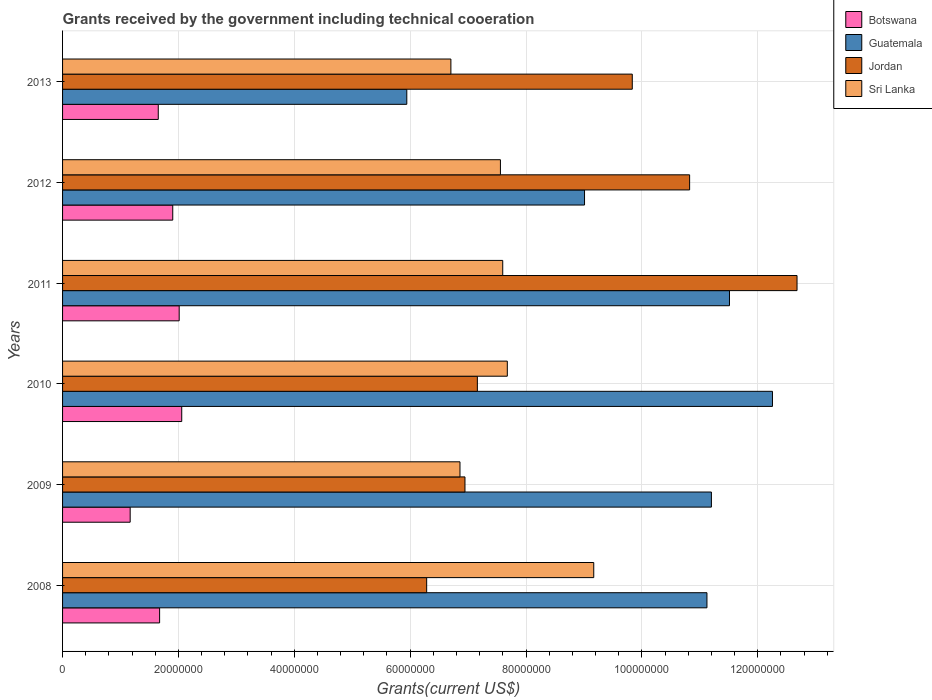How many different coloured bars are there?
Make the answer very short. 4. In how many cases, is the number of bars for a given year not equal to the number of legend labels?
Your answer should be very brief. 0. What is the total grants received by the government in Jordan in 2011?
Make the answer very short. 1.27e+08. Across all years, what is the maximum total grants received by the government in Sri Lanka?
Ensure brevity in your answer.  9.17e+07. Across all years, what is the minimum total grants received by the government in Guatemala?
Give a very brief answer. 5.94e+07. In which year was the total grants received by the government in Jordan minimum?
Offer a terse response. 2008. What is the total total grants received by the government in Jordan in the graph?
Your response must be concise. 5.37e+08. What is the difference between the total grants received by the government in Sri Lanka in 2010 and that in 2012?
Provide a succinct answer. 1.19e+06. What is the difference between the total grants received by the government in Guatemala in 2010 and the total grants received by the government in Sri Lanka in 2013?
Offer a terse response. 5.55e+07. What is the average total grants received by the government in Guatemala per year?
Offer a very short reply. 1.02e+08. In the year 2013, what is the difference between the total grants received by the government in Botswana and total grants received by the government in Sri Lanka?
Your answer should be compact. -5.05e+07. What is the ratio of the total grants received by the government in Botswana in 2009 to that in 2012?
Ensure brevity in your answer.  0.61. What is the difference between the highest and the second highest total grants received by the government in Guatemala?
Give a very brief answer. 7.42e+06. What is the difference between the highest and the lowest total grants received by the government in Guatemala?
Provide a succinct answer. 6.31e+07. In how many years, is the total grants received by the government in Jordan greater than the average total grants received by the government in Jordan taken over all years?
Provide a short and direct response. 3. What does the 4th bar from the top in 2012 represents?
Make the answer very short. Botswana. What does the 3rd bar from the bottom in 2011 represents?
Make the answer very short. Jordan. How many bars are there?
Offer a very short reply. 24. Are all the bars in the graph horizontal?
Your answer should be compact. Yes. How many years are there in the graph?
Offer a very short reply. 6. What is the difference between two consecutive major ticks on the X-axis?
Your answer should be very brief. 2.00e+07. Does the graph contain any zero values?
Your response must be concise. No. Does the graph contain grids?
Your response must be concise. Yes. Where does the legend appear in the graph?
Provide a short and direct response. Top right. What is the title of the graph?
Your answer should be very brief. Grants received by the government including technical cooeration. What is the label or title of the X-axis?
Offer a very short reply. Grants(current US$). What is the label or title of the Y-axis?
Keep it short and to the point. Years. What is the Grants(current US$) in Botswana in 2008?
Your answer should be compact. 1.68e+07. What is the Grants(current US$) in Guatemala in 2008?
Offer a terse response. 1.11e+08. What is the Grants(current US$) in Jordan in 2008?
Make the answer very short. 6.28e+07. What is the Grants(current US$) of Sri Lanka in 2008?
Offer a very short reply. 9.17e+07. What is the Grants(current US$) in Botswana in 2009?
Your response must be concise. 1.17e+07. What is the Grants(current US$) in Guatemala in 2009?
Keep it short and to the point. 1.12e+08. What is the Grants(current US$) in Jordan in 2009?
Keep it short and to the point. 6.95e+07. What is the Grants(current US$) of Sri Lanka in 2009?
Your answer should be compact. 6.86e+07. What is the Grants(current US$) in Botswana in 2010?
Make the answer very short. 2.06e+07. What is the Grants(current US$) in Guatemala in 2010?
Offer a very short reply. 1.23e+08. What is the Grants(current US$) of Jordan in 2010?
Keep it short and to the point. 7.16e+07. What is the Grants(current US$) in Sri Lanka in 2010?
Provide a short and direct response. 7.68e+07. What is the Grants(current US$) of Botswana in 2011?
Your response must be concise. 2.01e+07. What is the Grants(current US$) in Guatemala in 2011?
Provide a short and direct response. 1.15e+08. What is the Grants(current US$) of Jordan in 2011?
Offer a very short reply. 1.27e+08. What is the Grants(current US$) of Sri Lanka in 2011?
Your response must be concise. 7.60e+07. What is the Grants(current US$) in Botswana in 2012?
Offer a terse response. 1.90e+07. What is the Grants(current US$) of Guatemala in 2012?
Provide a short and direct response. 9.01e+07. What is the Grants(current US$) in Jordan in 2012?
Your response must be concise. 1.08e+08. What is the Grants(current US$) of Sri Lanka in 2012?
Ensure brevity in your answer.  7.56e+07. What is the Grants(current US$) in Botswana in 2013?
Provide a succinct answer. 1.65e+07. What is the Grants(current US$) of Guatemala in 2013?
Make the answer very short. 5.94e+07. What is the Grants(current US$) in Jordan in 2013?
Offer a terse response. 9.83e+07. What is the Grants(current US$) of Sri Lanka in 2013?
Give a very brief answer. 6.70e+07. Across all years, what is the maximum Grants(current US$) of Botswana?
Give a very brief answer. 2.06e+07. Across all years, what is the maximum Grants(current US$) of Guatemala?
Offer a very short reply. 1.23e+08. Across all years, what is the maximum Grants(current US$) of Jordan?
Offer a very short reply. 1.27e+08. Across all years, what is the maximum Grants(current US$) of Sri Lanka?
Your answer should be compact. 9.17e+07. Across all years, what is the minimum Grants(current US$) in Botswana?
Your answer should be compact. 1.17e+07. Across all years, what is the minimum Grants(current US$) in Guatemala?
Give a very brief answer. 5.94e+07. Across all years, what is the minimum Grants(current US$) of Jordan?
Make the answer very short. 6.28e+07. Across all years, what is the minimum Grants(current US$) in Sri Lanka?
Give a very brief answer. 6.70e+07. What is the total Grants(current US$) of Botswana in the graph?
Your response must be concise. 1.05e+08. What is the total Grants(current US$) in Guatemala in the graph?
Your response must be concise. 6.10e+08. What is the total Grants(current US$) of Jordan in the graph?
Your answer should be compact. 5.37e+08. What is the total Grants(current US$) in Sri Lanka in the graph?
Provide a short and direct response. 4.56e+08. What is the difference between the Grants(current US$) of Botswana in 2008 and that in 2009?
Ensure brevity in your answer.  5.08e+06. What is the difference between the Grants(current US$) of Guatemala in 2008 and that in 2009?
Provide a succinct answer. -7.70e+05. What is the difference between the Grants(current US$) in Jordan in 2008 and that in 2009?
Your response must be concise. -6.61e+06. What is the difference between the Grants(current US$) of Sri Lanka in 2008 and that in 2009?
Your answer should be compact. 2.31e+07. What is the difference between the Grants(current US$) in Botswana in 2008 and that in 2010?
Provide a short and direct response. -3.82e+06. What is the difference between the Grants(current US$) of Guatemala in 2008 and that in 2010?
Your response must be concise. -1.13e+07. What is the difference between the Grants(current US$) of Jordan in 2008 and that in 2010?
Your answer should be compact. -8.75e+06. What is the difference between the Grants(current US$) of Sri Lanka in 2008 and that in 2010?
Make the answer very short. 1.49e+07. What is the difference between the Grants(current US$) in Botswana in 2008 and that in 2011?
Provide a succinct answer. -3.38e+06. What is the difference between the Grants(current US$) of Guatemala in 2008 and that in 2011?
Your response must be concise. -3.89e+06. What is the difference between the Grants(current US$) in Jordan in 2008 and that in 2011?
Provide a short and direct response. -6.39e+07. What is the difference between the Grants(current US$) in Sri Lanka in 2008 and that in 2011?
Give a very brief answer. 1.57e+07. What is the difference between the Grants(current US$) in Botswana in 2008 and that in 2012?
Ensure brevity in your answer.  -2.27e+06. What is the difference between the Grants(current US$) in Guatemala in 2008 and that in 2012?
Make the answer very short. 2.11e+07. What is the difference between the Grants(current US$) in Jordan in 2008 and that in 2012?
Provide a short and direct response. -4.54e+07. What is the difference between the Grants(current US$) of Sri Lanka in 2008 and that in 2012?
Provide a succinct answer. 1.61e+07. What is the difference between the Grants(current US$) of Botswana in 2008 and that in 2013?
Provide a succinct answer. 2.30e+05. What is the difference between the Grants(current US$) in Guatemala in 2008 and that in 2013?
Provide a short and direct response. 5.18e+07. What is the difference between the Grants(current US$) of Jordan in 2008 and that in 2013?
Offer a terse response. -3.55e+07. What is the difference between the Grants(current US$) in Sri Lanka in 2008 and that in 2013?
Your response must be concise. 2.47e+07. What is the difference between the Grants(current US$) in Botswana in 2009 and that in 2010?
Make the answer very short. -8.90e+06. What is the difference between the Grants(current US$) in Guatemala in 2009 and that in 2010?
Offer a very short reply. -1.05e+07. What is the difference between the Grants(current US$) of Jordan in 2009 and that in 2010?
Provide a succinct answer. -2.14e+06. What is the difference between the Grants(current US$) of Sri Lanka in 2009 and that in 2010?
Give a very brief answer. -8.17e+06. What is the difference between the Grants(current US$) of Botswana in 2009 and that in 2011?
Provide a short and direct response. -8.46e+06. What is the difference between the Grants(current US$) in Guatemala in 2009 and that in 2011?
Provide a succinct answer. -3.12e+06. What is the difference between the Grants(current US$) of Jordan in 2009 and that in 2011?
Your answer should be compact. -5.73e+07. What is the difference between the Grants(current US$) in Sri Lanka in 2009 and that in 2011?
Offer a terse response. -7.38e+06. What is the difference between the Grants(current US$) of Botswana in 2009 and that in 2012?
Offer a very short reply. -7.35e+06. What is the difference between the Grants(current US$) of Guatemala in 2009 and that in 2012?
Keep it short and to the point. 2.19e+07. What is the difference between the Grants(current US$) of Jordan in 2009 and that in 2012?
Give a very brief answer. -3.88e+07. What is the difference between the Grants(current US$) of Sri Lanka in 2009 and that in 2012?
Your answer should be very brief. -6.98e+06. What is the difference between the Grants(current US$) in Botswana in 2009 and that in 2013?
Your response must be concise. -4.85e+06. What is the difference between the Grants(current US$) in Guatemala in 2009 and that in 2013?
Ensure brevity in your answer.  5.26e+07. What is the difference between the Grants(current US$) in Jordan in 2009 and that in 2013?
Your answer should be compact. -2.89e+07. What is the difference between the Grants(current US$) of Sri Lanka in 2009 and that in 2013?
Keep it short and to the point. 1.57e+06. What is the difference between the Grants(current US$) in Guatemala in 2010 and that in 2011?
Ensure brevity in your answer.  7.42e+06. What is the difference between the Grants(current US$) of Jordan in 2010 and that in 2011?
Provide a short and direct response. -5.52e+07. What is the difference between the Grants(current US$) in Sri Lanka in 2010 and that in 2011?
Your answer should be compact. 7.90e+05. What is the difference between the Grants(current US$) in Botswana in 2010 and that in 2012?
Provide a succinct answer. 1.55e+06. What is the difference between the Grants(current US$) in Guatemala in 2010 and that in 2012?
Your answer should be compact. 3.24e+07. What is the difference between the Grants(current US$) in Jordan in 2010 and that in 2012?
Provide a short and direct response. -3.66e+07. What is the difference between the Grants(current US$) of Sri Lanka in 2010 and that in 2012?
Ensure brevity in your answer.  1.19e+06. What is the difference between the Grants(current US$) of Botswana in 2010 and that in 2013?
Ensure brevity in your answer.  4.05e+06. What is the difference between the Grants(current US$) of Guatemala in 2010 and that in 2013?
Your response must be concise. 6.31e+07. What is the difference between the Grants(current US$) in Jordan in 2010 and that in 2013?
Give a very brief answer. -2.67e+07. What is the difference between the Grants(current US$) of Sri Lanka in 2010 and that in 2013?
Make the answer very short. 9.74e+06. What is the difference between the Grants(current US$) of Botswana in 2011 and that in 2012?
Keep it short and to the point. 1.11e+06. What is the difference between the Grants(current US$) of Guatemala in 2011 and that in 2012?
Offer a terse response. 2.50e+07. What is the difference between the Grants(current US$) in Jordan in 2011 and that in 2012?
Offer a terse response. 1.85e+07. What is the difference between the Grants(current US$) of Sri Lanka in 2011 and that in 2012?
Ensure brevity in your answer.  4.00e+05. What is the difference between the Grants(current US$) in Botswana in 2011 and that in 2013?
Your response must be concise. 3.61e+06. What is the difference between the Grants(current US$) in Guatemala in 2011 and that in 2013?
Provide a short and direct response. 5.57e+07. What is the difference between the Grants(current US$) in Jordan in 2011 and that in 2013?
Offer a very short reply. 2.84e+07. What is the difference between the Grants(current US$) in Sri Lanka in 2011 and that in 2013?
Offer a very short reply. 8.95e+06. What is the difference between the Grants(current US$) of Botswana in 2012 and that in 2013?
Your answer should be compact. 2.50e+06. What is the difference between the Grants(current US$) in Guatemala in 2012 and that in 2013?
Offer a terse response. 3.07e+07. What is the difference between the Grants(current US$) of Jordan in 2012 and that in 2013?
Offer a very short reply. 9.90e+06. What is the difference between the Grants(current US$) in Sri Lanka in 2012 and that in 2013?
Keep it short and to the point. 8.55e+06. What is the difference between the Grants(current US$) in Botswana in 2008 and the Grants(current US$) in Guatemala in 2009?
Offer a terse response. -9.52e+07. What is the difference between the Grants(current US$) in Botswana in 2008 and the Grants(current US$) in Jordan in 2009?
Ensure brevity in your answer.  -5.27e+07. What is the difference between the Grants(current US$) in Botswana in 2008 and the Grants(current US$) in Sri Lanka in 2009?
Give a very brief answer. -5.18e+07. What is the difference between the Grants(current US$) in Guatemala in 2008 and the Grants(current US$) in Jordan in 2009?
Offer a terse response. 4.18e+07. What is the difference between the Grants(current US$) of Guatemala in 2008 and the Grants(current US$) of Sri Lanka in 2009?
Offer a terse response. 4.26e+07. What is the difference between the Grants(current US$) in Jordan in 2008 and the Grants(current US$) in Sri Lanka in 2009?
Your answer should be very brief. -5.75e+06. What is the difference between the Grants(current US$) of Botswana in 2008 and the Grants(current US$) of Guatemala in 2010?
Offer a very short reply. -1.06e+08. What is the difference between the Grants(current US$) in Botswana in 2008 and the Grants(current US$) in Jordan in 2010?
Your response must be concise. -5.48e+07. What is the difference between the Grants(current US$) of Botswana in 2008 and the Grants(current US$) of Sri Lanka in 2010?
Offer a very short reply. -6.00e+07. What is the difference between the Grants(current US$) in Guatemala in 2008 and the Grants(current US$) in Jordan in 2010?
Keep it short and to the point. 3.96e+07. What is the difference between the Grants(current US$) in Guatemala in 2008 and the Grants(current US$) in Sri Lanka in 2010?
Your response must be concise. 3.45e+07. What is the difference between the Grants(current US$) in Jordan in 2008 and the Grants(current US$) in Sri Lanka in 2010?
Your answer should be very brief. -1.39e+07. What is the difference between the Grants(current US$) in Botswana in 2008 and the Grants(current US$) in Guatemala in 2011?
Provide a short and direct response. -9.84e+07. What is the difference between the Grants(current US$) in Botswana in 2008 and the Grants(current US$) in Jordan in 2011?
Keep it short and to the point. -1.10e+08. What is the difference between the Grants(current US$) of Botswana in 2008 and the Grants(current US$) of Sri Lanka in 2011?
Make the answer very short. -5.92e+07. What is the difference between the Grants(current US$) in Guatemala in 2008 and the Grants(current US$) in Jordan in 2011?
Your response must be concise. -1.56e+07. What is the difference between the Grants(current US$) of Guatemala in 2008 and the Grants(current US$) of Sri Lanka in 2011?
Your response must be concise. 3.52e+07. What is the difference between the Grants(current US$) in Jordan in 2008 and the Grants(current US$) in Sri Lanka in 2011?
Keep it short and to the point. -1.31e+07. What is the difference between the Grants(current US$) in Botswana in 2008 and the Grants(current US$) in Guatemala in 2012?
Offer a very short reply. -7.34e+07. What is the difference between the Grants(current US$) of Botswana in 2008 and the Grants(current US$) of Jordan in 2012?
Offer a terse response. -9.15e+07. What is the difference between the Grants(current US$) of Botswana in 2008 and the Grants(current US$) of Sri Lanka in 2012?
Your answer should be compact. -5.88e+07. What is the difference between the Grants(current US$) of Guatemala in 2008 and the Grants(current US$) of Jordan in 2012?
Give a very brief answer. 2.99e+06. What is the difference between the Grants(current US$) of Guatemala in 2008 and the Grants(current US$) of Sri Lanka in 2012?
Offer a terse response. 3.56e+07. What is the difference between the Grants(current US$) in Jordan in 2008 and the Grants(current US$) in Sri Lanka in 2012?
Make the answer very short. -1.27e+07. What is the difference between the Grants(current US$) of Botswana in 2008 and the Grants(current US$) of Guatemala in 2013?
Your response must be concise. -4.27e+07. What is the difference between the Grants(current US$) of Botswana in 2008 and the Grants(current US$) of Jordan in 2013?
Offer a terse response. -8.16e+07. What is the difference between the Grants(current US$) in Botswana in 2008 and the Grants(current US$) in Sri Lanka in 2013?
Make the answer very short. -5.03e+07. What is the difference between the Grants(current US$) in Guatemala in 2008 and the Grants(current US$) in Jordan in 2013?
Provide a short and direct response. 1.29e+07. What is the difference between the Grants(current US$) of Guatemala in 2008 and the Grants(current US$) of Sri Lanka in 2013?
Provide a short and direct response. 4.42e+07. What is the difference between the Grants(current US$) of Jordan in 2008 and the Grants(current US$) of Sri Lanka in 2013?
Offer a very short reply. -4.18e+06. What is the difference between the Grants(current US$) in Botswana in 2009 and the Grants(current US$) in Guatemala in 2010?
Give a very brief answer. -1.11e+08. What is the difference between the Grants(current US$) in Botswana in 2009 and the Grants(current US$) in Jordan in 2010?
Provide a short and direct response. -5.99e+07. What is the difference between the Grants(current US$) of Botswana in 2009 and the Grants(current US$) of Sri Lanka in 2010?
Your response must be concise. -6.51e+07. What is the difference between the Grants(current US$) in Guatemala in 2009 and the Grants(current US$) in Jordan in 2010?
Your answer should be compact. 4.04e+07. What is the difference between the Grants(current US$) of Guatemala in 2009 and the Grants(current US$) of Sri Lanka in 2010?
Your answer should be very brief. 3.52e+07. What is the difference between the Grants(current US$) in Jordan in 2009 and the Grants(current US$) in Sri Lanka in 2010?
Your answer should be compact. -7.31e+06. What is the difference between the Grants(current US$) in Botswana in 2009 and the Grants(current US$) in Guatemala in 2011?
Provide a succinct answer. -1.03e+08. What is the difference between the Grants(current US$) in Botswana in 2009 and the Grants(current US$) in Jordan in 2011?
Your response must be concise. -1.15e+08. What is the difference between the Grants(current US$) in Botswana in 2009 and the Grants(current US$) in Sri Lanka in 2011?
Offer a very short reply. -6.43e+07. What is the difference between the Grants(current US$) of Guatemala in 2009 and the Grants(current US$) of Jordan in 2011?
Your response must be concise. -1.48e+07. What is the difference between the Grants(current US$) of Guatemala in 2009 and the Grants(current US$) of Sri Lanka in 2011?
Keep it short and to the point. 3.60e+07. What is the difference between the Grants(current US$) in Jordan in 2009 and the Grants(current US$) in Sri Lanka in 2011?
Your answer should be very brief. -6.52e+06. What is the difference between the Grants(current US$) in Botswana in 2009 and the Grants(current US$) in Guatemala in 2012?
Offer a very short reply. -7.84e+07. What is the difference between the Grants(current US$) of Botswana in 2009 and the Grants(current US$) of Jordan in 2012?
Ensure brevity in your answer.  -9.66e+07. What is the difference between the Grants(current US$) of Botswana in 2009 and the Grants(current US$) of Sri Lanka in 2012?
Ensure brevity in your answer.  -6.39e+07. What is the difference between the Grants(current US$) in Guatemala in 2009 and the Grants(current US$) in Jordan in 2012?
Offer a very short reply. 3.76e+06. What is the difference between the Grants(current US$) in Guatemala in 2009 and the Grants(current US$) in Sri Lanka in 2012?
Make the answer very short. 3.64e+07. What is the difference between the Grants(current US$) in Jordan in 2009 and the Grants(current US$) in Sri Lanka in 2012?
Keep it short and to the point. -6.12e+06. What is the difference between the Grants(current US$) of Botswana in 2009 and the Grants(current US$) of Guatemala in 2013?
Your answer should be compact. -4.78e+07. What is the difference between the Grants(current US$) in Botswana in 2009 and the Grants(current US$) in Jordan in 2013?
Your answer should be compact. -8.67e+07. What is the difference between the Grants(current US$) in Botswana in 2009 and the Grants(current US$) in Sri Lanka in 2013?
Your answer should be compact. -5.54e+07. What is the difference between the Grants(current US$) of Guatemala in 2009 and the Grants(current US$) of Jordan in 2013?
Provide a succinct answer. 1.37e+07. What is the difference between the Grants(current US$) in Guatemala in 2009 and the Grants(current US$) in Sri Lanka in 2013?
Offer a terse response. 4.50e+07. What is the difference between the Grants(current US$) of Jordan in 2009 and the Grants(current US$) of Sri Lanka in 2013?
Your response must be concise. 2.43e+06. What is the difference between the Grants(current US$) in Botswana in 2010 and the Grants(current US$) in Guatemala in 2011?
Give a very brief answer. -9.46e+07. What is the difference between the Grants(current US$) in Botswana in 2010 and the Grants(current US$) in Jordan in 2011?
Offer a very short reply. -1.06e+08. What is the difference between the Grants(current US$) in Botswana in 2010 and the Grants(current US$) in Sri Lanka in 2011?
Your response must be concise. -5.54e+07. What is the difference between the Grants(current US$) in Guatemala in 2010 and the Grants(current US$) in Jordan in 2011?
Offer a terse response. -4.24e+06. What is the difference between the Grants(current US$) of Guatemala in 2010 and the Grants(current US$) of Sri Lanka in 2011?
Ensure brevity in your answer.  4.66e+07. What is the difference between the Grants(current US$) of Jordan in 2010 and the Grants(current US$) of Sri Lanka in 2011?
Offer a terse response. -4.38e+06. What is the difference between the Grants(current US$) of Botswana in 2010 and the Grants(current US$) of Guatemala in 2012?
Provide a succinct answer. -6.95e+07. What is the difference between the Grants(current US$) in Botswana in 2010 and the Grants(current US$) in Jordan in 2012?
Offer a very short reply. -8.77e+07. What is the difference between the Grants(current US$) of Botswana in 2010 and the Grants(current US$) of Sri Lanka in 2012?
Offer a terse response. -5.50e+07. What is the difference between the Grants(current US$) in Guatemala in 2010 and the Grants(current US$) in Jordan in 2012?
Keep it short and to the point. 1.43e+07. What is the difference between the Grants(current US$) of Guatemala in 2010 and the Grants(current US$) of Sri Lanka in 2012?
Provide a succinct answer. 4.70e+07. What is the difference between the Grants(current US$) in Jordan in 2010 and the Grants(current US$) in Sri Lanka in 2012?
Make the answer very short. -3.98e+06. What is the difference between the Grants(current US$) of Botswana in 2010 and the Grants(current US$) of Guatemala in 2013?
Your answer should be compact. -3.88e+07. What is the difference between the Grants(current US$) of Botswana in 2010 and the Grants(current US$) of Jordan in 2013?
Offer a terse response. -7.78e+07. What is the difference between the Grants(current US$) in Botswana in 2010 and the Grants(current US$) in Sri Lanka in 2013?
Make the answer very short. -4.65e+07. What is the difference between the Grants(current US$) of Guatemala in 2010 and the Grants(current US$) of Jordan in 2013?
Offer a very short reply. 2.42e+07. What is the difference between the Grants(current US$) in Guatemala in 2010 and the Grants(current US$) in Sri Lanka in 2013?
Offer a terse response. 5.55e+07. What is the difference between the Grants(current US$) in Jordan in 2010 and the Grants(current US$) in Sri Lanka in 2013?
Ensure brevity in your answer.  4.57e+06. What is the difference between the Grants(current US$) of Botswana in 2011 and the Grants(current US$) of Guatemala in 2012?
Your answer should be very brief. -7.00e+07. What is the difference between the Grants(current US$) in Botswana in 2011 and the Grants(current US$) in Jordan in 2012?
Keep it short and to the point. -8.81e+07. What is the difference between the Grants(current US$) of Botswana in 2011 and the Grants(current US$) of Sri Lanka in 2012?
Keep it short and to the point. -5.54e+07. What is the difference between the Grants(current US$) of Guatemala in 2011 and the Grants(current US$) of Jordan in 2012?
Give a very brief answer. 6.88e+06. What is the difference between the Grants(current US$) of Guatemala in 2011 and the Grants(current US$) of Sri Lanka in 2012?
Provide a succinct answer. 3.95e+07. What is the difference between the Grants(current US$) in Jordan in 2011 and the Grants(current US$) in Sri Lanka in 2012?
Provide a succinct answer. 5.12e+07. What is the difference between the Grants(current US$) in Botswana in 2011 and the Grants(current US$) in Guatemala in 2013?
Offer a terse response. -3.93e+07. What is the difference between the Grants(current US$) in Botswana in 2011 and the Grants(current US$) in Jordan in 2013?
Keep it short and to the point. -7.82e+07. What is the difference between the Grants(current US$) of Botswana in 2011 and the Grants(current US$) of Sri Lanka in 2013?
Provide a short and direct response. -4.69e+07. What is the difference between the Grants(current US$) in Guatemala in 2011 and the Grants(current US$) in Jordan in 2013?
Give a very brief answer. 1.68e+07. What is the difference between the Grants(current US$) of Guatemala in 2011 and the Grants(current US$) of Sri Lanka in 2013?
Keep it short and to the point. 4.81e+07. What is the difference between the Grants(current US$) in Jordan in 2011 and the Grants(current US$) in Sri Lanka in 2013?
Your answer should be very brief. 5.98e+07. What is the difference between the Grants(current US$) in Botswana in 2012 and the Grants(current US$) in Guatemala in 2013?
Make the answer very short. -4.04e+07. What is the difference between the Grants(current US$) in Botswana in 2012 and the Grants(current US$) in Jordan in 2013?
Your response must be concise. -7.93e+07. What is the difference between the Grants(current US$) in Botswana in 2012 and the Grants(current US$) in Sri Lanka in 2013?
Give a very brief answer. -4.80e+07. What is the difference between the Grants(current US$) of Guatemala in 2012 and the Grants(current US$) of Jordan in 2013?
Provide a succinct answer. -8.24e+06. What is the difference between the Grants(current US$) in Guatemala in 2012 and the Grants(current US$) in Sri Lanka in 2013?
Provide a succinct answer. 2.31e+07. What is the difference between the Grants(current US$) of Jordan in 2012 and the Grants(current US$) of Sri Lanka in 2013?
Offer a terse response. 4.12e+07. What is the average Grants(current US$) in Botswana per year?
Offer a very short reply. 1.74e+07. What is the average Grants(current US$) in Guatemala per year?
Offer a terse response. 1.02e+08. What is the average Grants(current US$) in Jordan per year?
Make the answer very short. 8.95e+07. What is the average Grants(current US$) in Sri Lanka per year?
Make the answer very short. 7.59e+07. In the year 2008, what is the difference between the Grants(current US$) of Botswana and Grants(current US$) of Guatemala?
Offer a very short reply. -9.45e+07. In the year 2008, what is the difference between the Grants(current US$) of Botswana and Grants(current US$) of Jordan?
Keep it short and to the point. -4.61e+07. In the year 2008, what is the difference between the Grants(current US$) of Botswana and Grants(current US$) of Sri Lanka?
Provide a succinct answer. -7.49e+07. In the year 2008, what is the difference between the Grants(current US$) in Guatemala and Grants(current US$) in Jordan?
Offer a terse response. 4.84e+07. In the year 2008, what is the difference between the Grants(current US$) in Guatemala and Grants(current US$) in Sri Lanka?
Your answer should be compact. 1.95e+07. In the year 2008, what is the difference between the Grants(current US$) in Jordan and Grants(current US$) in Sri Lanka?
Keep it short and to the point. -2.88e+07. In the year 2009, what is the difference between the Grants(current US$) of Botswana and Grants(current US$) of Guatemala?
Your response must be concise. -1.00e+08. In the year 2009, what is the difference between the Grants(current US$) of Botswana and Grants(current US$) of Jordan?
Keep it short and to the point. -5.78e+07. In the year 2009, what is the difference between the Grants(current US$) in Botswana and Grants(current US$) in Sri Lanka?
Keep it short and to the point. -5.69e+07. In the year 2009, what is the difference between the Grants(current US$) in Guatemala and Grants(current US$) in Jordan?
Ensure brevity in your answer.  4.25e+07. In the year 2009, what is the difference between the Grants(current US$) in Guatemala and Grants(current US$) in Sri Lanka?
Offer a very short reply. 4.34e+07. In the year 2009, what is the difference between the Grants(current US$) of Jordan and Grants(current US$) of Sri Lanka?
Give a very brief answer. 8.60e+05. In the year 2010, what is the difference between the Grants(current US$) of Botswana and Grants(current US$) of Guatemala?
Provide a short and direct response. -1.02e+08. In the year 2010, what is the difference between the Grants(current US$) of Botswana and Grants(current US$) of Jordan?
Make the answer very short. -5.10e+07. In the year 2010, what is the difference between the Grants(current US$) of Botswana and Grants(current US$) of Sri Lanka?
Provide a succinct answer. -5.62e+07. In the year 2010, what is the difference between the Grants(current US$) of Guatemala and Grants(current US$) of Jordan?
Your response must be concise. 5.09e+07. In the year 2010, what is the difference between the Grants(current US$) in Guatemala and Grants(current US$) in Sri Lanka?
Your answer should be very brief. 4.58e+07. In the year 2010, what is the difference between the Grants(current US$) of Jordan and Grants(current US$) of Sri Lanka?
Make the answer very short. -5.17e+06. In the year 2011, what is the difference between the Grants(current US$) in Botswana and Grants(current US$) in Guatemala?
Give a very brief answer. -9.50e+07. In the year 2011, what is the difference between the Grants(current US$) in Botswana and Grants(current US$) in Jordan?
Offer a terse response. -1.07e+08. In the year 2011, what is the difference between the Grants(current US$) in Botswana and Grants(current US$) in Sri Lanka?
Provide a succinct answer. -5.58e+07. In the year 2011, what is the difference between the Grants(current US$) in Guatemala and Grants(current US$) in Jordan?
Make the answer very short. -1.17e+07. In the year 2011, what is the difference between the Grants(current US$) in Guatemala and Grants(current US$) in Sri Lanka?
Ensure brevity in your answer.  3.91e+07. In the year 2011, what is the difference between the Grants(current US$) in Jordan and Grants(current US$) in Sri Lanka?
Your response must be concise. 5.08e+07. In the year 2012, what is the difference between the Grants(current US$) in Botswana and Grants(current US$) in Guatemala?
Make the answer very short. -7.11e+07. In the year 2012, what is the difference between the Grants(current US$) in Botswana and Grants(current US$) in Jordan?
Offer a very short reply. -8.92e+07. In the year 2012, what is the difference between the Grants(current US$) of Botswana and Grants(current US$) of Sri Lanka?
Provide a succinct answer. -5.66e+07. In the year 2012, what is the difference between the Grants(current US$) of Guatemala and Grants(current US$) of Jordan?
Give a very brief answer. -1.81e+07. In the year 2012, what is the difference between the Grants(current US$) of Guatemala and Grants(current US$) of Sri Lanka?
Your response must be concise. 1.45e+07. In the year 2012, what is the difference between the Grants(current US$) of Jordan and Grants(current US$) of Sri Lanka?
Offer a very short reply. 3.27e+07. In the year 2013, what is the difference between the Grants(current US$) in Botswana and Grants(current US$) in Guatemala?
Offer a very short reply. -4.29e+07. In the year 2013, what is the difference between the Grants(current US$) in Botswana and Grants(current US$) in Jordan?
Offer a very short reply. -8.18e+07. In the year 2013, what is the difference between the Grants(current US$) of Botswana and Grants(current US$) of Sri Lanka?
Ensure brevity in your answer.  -5.05e+07. In the year 2013, what is the difference between the Grants(current US$) of Guatemala and Grants(current US$) of Jordan?
Your answer should be very brief. -3.89e+07. In the year 2013, what is the difference between the Grants(current US$) in Guatemala and Grants(current US$) in Sri Lanka?
Give a very brief answer. -7.61e+06. In the year 2013, what is the difference between the Grants(current US$) of Jordan and Grants(current US$) of Sri Lanka?
Ensure brevity in your answer.  3.13e+07. What is the ratio of the Grants(current US$) of Botswana in 2008 to that in 2009?
Your answer should be compact. 1.44. What is the ratio of the Grants(current US$) of Guatemala in 2008 to that in 2009?
Your answer should be very brief. 0.99. What is the ratio of the Grants(current US$) of Jordan in 2008 to that in 2009?
Provide a short and direct response. 0.9. What is the ratio of the Grants(current US$) of Sri Lanka in 2008 to that in 2009?
Give a very brief answer. 1.34. What is the ratio of the Grants(current US$) of Botswana in 2008 to that in 2010?
Make the answer very short. 0.81. What is the ratio of the Grants(current US$) in Guatemala in 2008 to that in 2010?
Keep it short and to the point. 0.91. What is the ratio of the Grants(current US$) in Jordan in 2008 to that in 2010?
Your answer should be very brief. 0.88. What is the ratio of the Grants(current US$) of Sri Lanka in 2008 to that in 2010?
Ensure brevity in your answer.  1.19. What is the ratio of the Grants(current US$) in Botswana in 2008 to that in 2011?
Provide a short and direct response. 0.83. What is the ratio of the Grants(current US$) in Guatemala in 2008 to that in 2011?
Offer a very short reply. 0.97. What is the ratio of the Grants(current US$) of Jordan in 2008 to that in 2011?
Your response must be concise. 0.5. What is the ratio of the Grants(current US$) in Sri Lanka in 2008 to that in 2011?
Offer a very short reply. 1.21. What is the ratio of the Grants(current US$) in Botswana in 2008 to that in 2012?
Your response must be concise. 0.88. What is the ratio of the Grants(current US$) in Guatemala in 2008 to that in 2012?
Your response must be concise. 1.23. What is the ratio of the Grants(current US$) of Jordan in 2008 to that in 2012?
Offer a terse response. 0.58. What is the ratio of the Grants(current US$) in Sri Lanka in 2008 to that in 2012?
Your response must be concise. 1.21. What is the ratio of the Grants(current US$) of Botswana in 2008 to that in 2013?
Make the answer very short. 1.01. What is the ratio of the Grants(current US$) in Guatemala in 2008 to that in 2013?
Your answer should be very brief. 1.87. What is the ratio of the Grants(current US$) of Jordan in 2008 to that in 2013?
Offer a very short reply. 0.64. What is the ratio of the Grants(current US$) of Sri Lanka in 2008 to that in 2013?
Offer a terse response. 1.37. What is the ratio of the Grants(current US$) of Botswana in 2009 to that in 2010?
Keep it short and to the point. 0.57. What is the ratio of the Grants(current US$) of Guatemala in 2009 to that in 2010?
Offer a very short reply. 0.91. What is the ratio of the Grants(current US$) in Jordan in 2009 to that in 2010?
Ensure brevity in your answer.  0.97. What is the ratio of the Grants(current US$) of Sri Lanka in 2009 to that in 2010?
Ensure brevity in your answer.  0.89. What is the ratio of the Grants(current US$) of Botswana in 2009 to that in 2011?
Provide a short and direct response. 0.58. What is the ratio of the Grants(current US$) in Guatemala in 2009 to that in 2011?
Your response must be concise. 0.97. What is the ratio of the Grants(current US$) in Jordan in 2009 to that in 2011?
Make the answer very short. 0.55. What is the ratio of the Grants(current US$) in Sri Lanka in 2009 to that in 2011?
Your answer should be compact. 0.9. What is the ratio of the Grants(current US$) of Botswana in 2009 to that in 2012?
Offer a terse response. 0.61. What is the ratio of the Grants(current US$) in Guatemala in 2009 to that in 2012?
Provide a short and direct response. 1.24. What is the ratio of the Grants(current US$) of Jordan in 2009 to that in 2012?
Provide a succinct answer. 0.64. What is the ratio of the Grants(current US$) of Sri Lanka in 2009 to that in 2012?
Provide a succinct answer. 0.91. What is the ratio of the Grants(current US$) of Botswana in 2009 to that in 2013?
Offer a terse response. 0.71. What is the ratio of the Grants(current US$) in Guatemala in 2009 to that in 2013?
Give a very brief answer. 1.88. What is the ratio of the Grants(current US$) of Jordan in 2009 to that in 2013?
Your answer should be very brief. 0.71. What is the ratio of the Grants(current US$) of Sri Lanka in 2009 to that in 2013?
Offer a very short reply. 1.02. What is the ratio of the Grants(current US$) in Botswana in 2010 to that in 2011?
Give a very brief answer. 1.02. What is the ratio of the Grants(current US$) of Guatemala in 2010 to that in 2011?
Offer a very short reply. 1.06. What is the ratio of the Grants(current US$) of Jordan in 2010 to that in 2011?
Ensure brevity in your answer.  0.56. What is the ratio of the Grants(current US$) in Sri Lanka in 2010 to that in 2011?
Your answer should be compact. 1.01. What is the ratio of the Grants(current US$) in Botswana in 2010 to that in 2012?
Provide a succinct answer. 1.08. What is the ratio of the Grants(current US$) in Guatemala in 2010 to that in 2012?
Your response must be concise. 1.36. What is the ratio of the Grants(current US$) of Jordan in 2010 to that in 2012?
Make the answer very short. 0.66. What is the ratio of the Grants(current US$) of Sri Lanka in 2010 to that in 2012?
Provide a short and direct response. 1.02. What is the ratio of the Grants(current US$) in Botswana in 2010 to that in 2013?
Keep it short and to the point. 1.25. What is the ratio of the Grants(current US$) of Guatemala in 2010 to that in 2013?
Your answer should be compact. 2.06. What is the ratio of the Grants(current US$) in Jordan in 2010 to that in 2013?
Your response must be concise. 0.73. What is the ratio of the Grants(current US$) in Sri Lanka in 2010 to that in 2013?
Give a very brief answer. 1.15. What is the ratio of the Grants(current US$) of Botswana in 2011 to that in 2012?
Make the answer very short. 1.06. What is the ratio of the Grants(current US$) in Guatemala in 2011 to that in 2012?
Make the answer very short. 1.28. What is the ratio of the Grants(current US$) in Jordan in 2011 to that in 2012?
Keep it short and to the point. 1.17. What is the ratio of the Grants(current US$) of Botswana in 2011 to that in 2013?
Keep it short and to the point. 1.22. What is the ratio of the Grants(current US$) of Guatemala in 2011 to that in 2013?
Ensure brevity in your answer.  1.94. What is the ratio of the Grants(current US$) of Jordan in 2011 to that in 2013?
Provide a short and direct response. 1.29. What is the ratio of the Grants(current US$) in Sri Lanka in 2011 to that in 2013?
Keep it short and to the point. 1.13. What is the ratio of the Grants(current US$) of Botswana in 2012 to that in 2013?
Provide a succinct answer. 1.15. What is the ratio of the Grants(current US$) in Guatemala in 2012 to that in 2013?
Offer a very short reply. 1.52. What is the ratio of the Grants(current US$) in Jordan in 2012 to that in 2013?
Give a very brief answer. 1.1. What is the ratio of the Grants(current US$) of Sri Lanka in 2012 to that in 2013?
Offer a very short reply. 1.13. What is the difference between the highest and the second highest Grants(current US$) of Botswana?
Ensure brevity in your answer.  4.40e+05. What is the difference between the highest and the second highest Grants(current US$) of Guatemala?
Your answer should be very brief. 7.42e+06. What is the difference between the highest and the second highest Grants(current US$) of Jordan?
Keep it short and to the point. 1.85e+07. What is the difference between the highest and the second highest Grants(current US$) of Sri Lanka?
Keep it short and to the point. 1.49e+07. What is the difference between the highest and the lowest Grants(current US$) in Botswana?
Provide a short and direct response. 8.90e+06. What is the difference between the highest and the lowest Grants(current US$) in Guatemala?
Ensure brevity in your answer.  6.31e+07. What is the difference between the highest and the lowest Grants(current US$) of Jordan?
Ensure brevity in your answer.  6.39e+07. What is the difference between the highest and the lowest Grants(current US$) of Sri Lanka?
Give a very brief answer. 2.47e+07. 